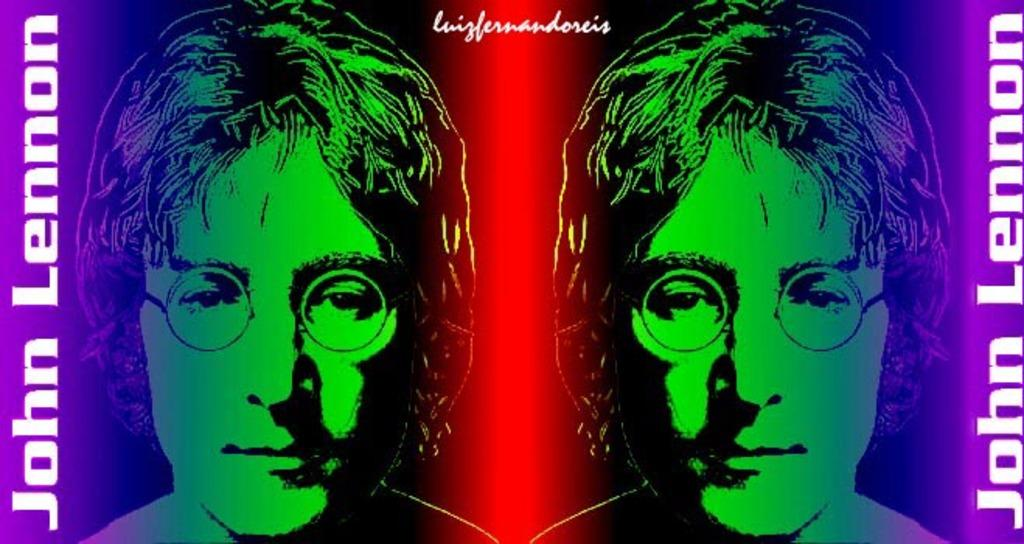How many people are in the image? There are two people in the image. Do the two people have any similarities? Yes, the two people have the same faces. Is there any text or writing present in the image? Yes, there is text or writing on the image. What type of crib is visible in the image? There is no crib present in the image. What is the caption for the image? The provided facts do not mention a caption for the image. 